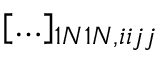<formula> <loc_0><loc_0><loc_500><loc_500>[ \dots ] _ { 1 N 1 N , i i j j }</formula> 